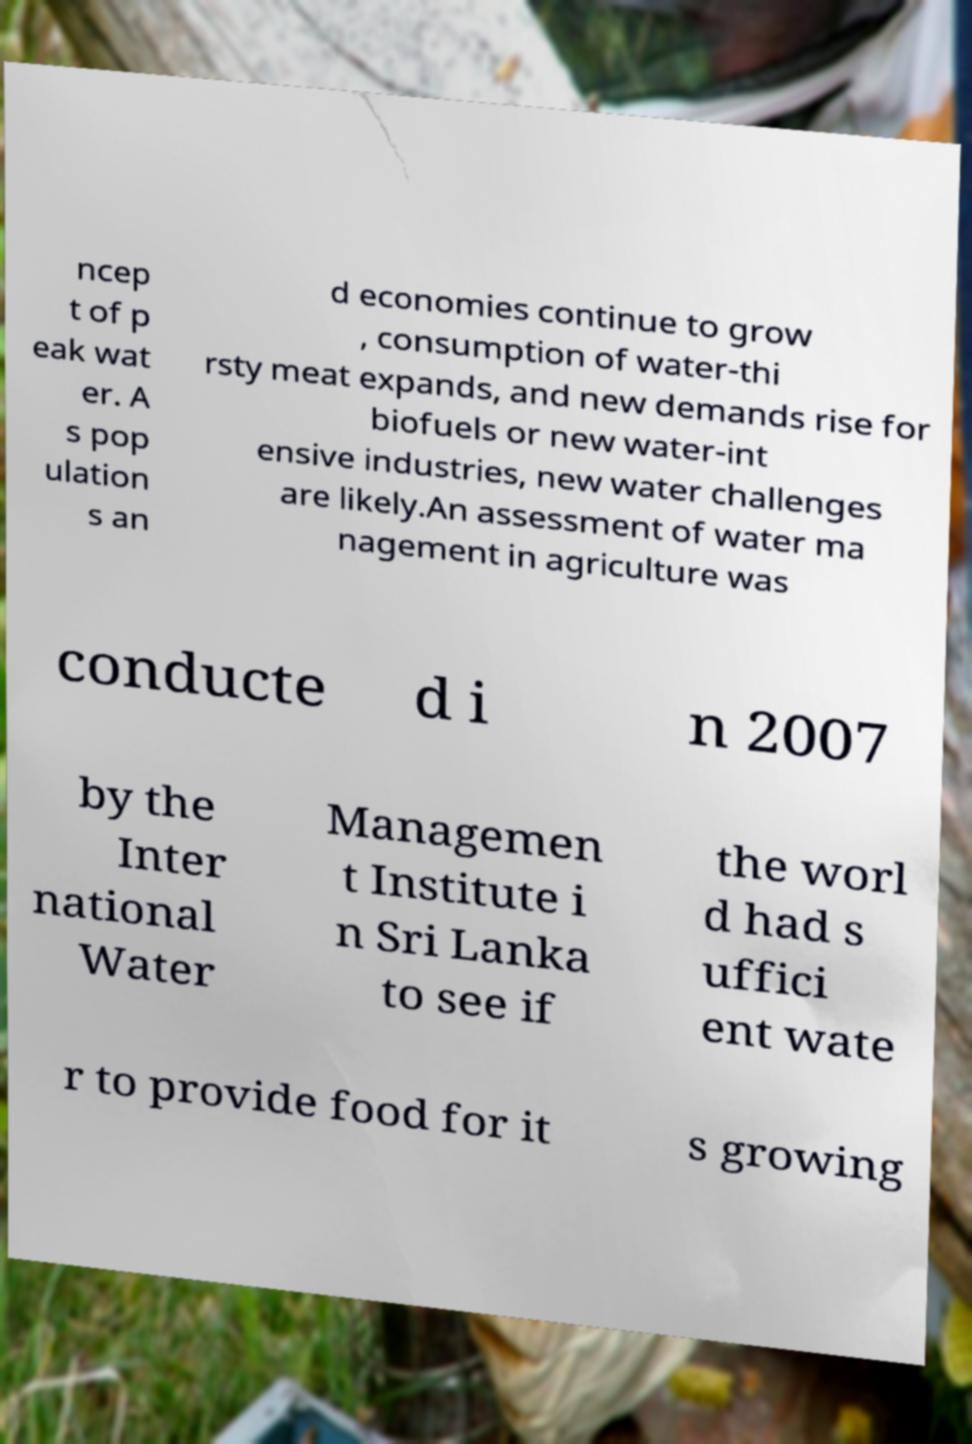Could you extract and type out the text from this image? ncep t of p eak wat er. A s pop ulation s an d economies continue to grow , consumption of water-thi rsty meat expands, and new demands rise for biofuels or new water-int ensive industries, new water challenges are likely.An assessment of water ma nagement in agriculture was conducte d i n 2007 by the Inter national Water Managemen t Institute i n Sri Lanka to see if the worl d had s uffici ent wate r to provide food for it s growing 